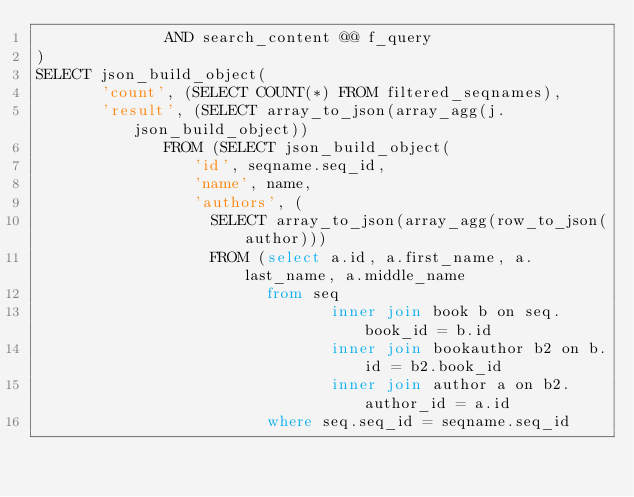<code> <loc_0><loc_0><loc_500><loc_500><_SQL_>              AND search_content @@ f_query
)
SELECT json_build_object(
       'count', (SELECT COUNT(*) FROM filtered_seqnames), 
       'result', (SELECT array_to_json(array_agg(j.json_build_object))
              FROM (SELECT json_build_object(
                 'id', seqname.seq_id,
                 'name', name,
                 'authors', (
                   SELECT array_to_json(array_agg(row_to_json(author)))
                   FROM (select a.id, a.first_name, a.last_name, a.middle_name
                         from seq
                                inner join book b on seq.book_id = b.id
                                inner join bookauthor b2 on b.id = b2.book_id
                                inner join author a on b2.author_id = a.id
                         where seq.seq_id = seqname.seq_id</code> 